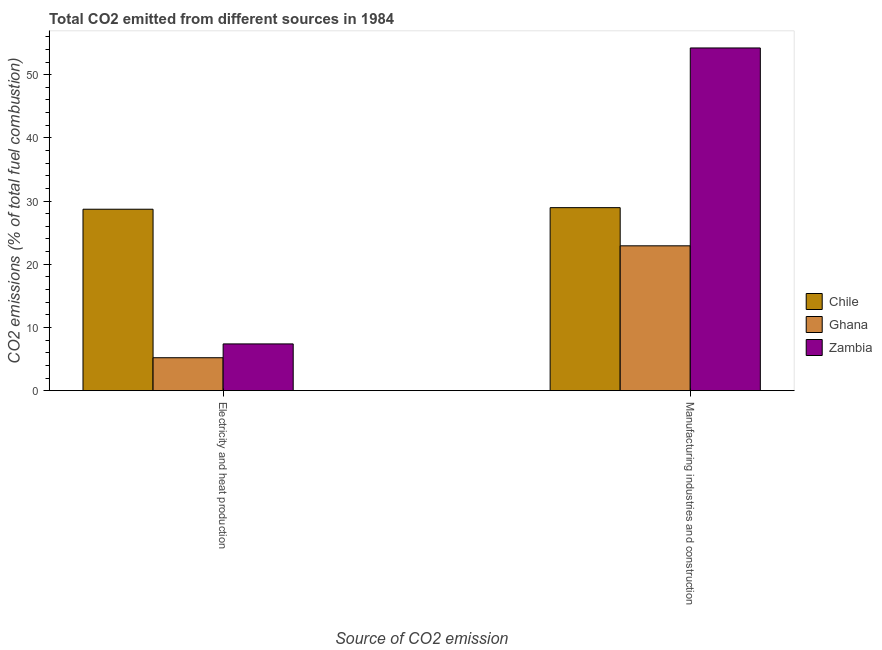How many different coloured bars are there?
Make the answer very short. 3. How many groups of bars are there?
Your response must be concise. 2. Are the number of bars on each tick of the X-axis equal?
Your answer should be compact. Yes. What is the label of the 2nd group of bars from the left?
Your response must be concise. Manufacturing industries and construction. What is the co2 emissions due to electricity and heat production in Zambia?
Offer a very short reply. 7.39. Across all countries, what is the maximum co2 emissions due to manufacturing industries?
Offer a terse response. 54.23. Across all countries, what is the minimum co2 emissions due to electricity and heat production?
Make the answer very short. 5.21. In which country was the co2 emissions due to manufacturing industries minimum?
Keep it short and to the point. Ghana. What is the total co2 emissions due to manufacturing industries in the graph?
Ensure brevity in your answer.  106.1. What is the difference between the co2 emissions due to manufacturing industries in Ghana and that in Chile?
Give a very brief answer. -6.04. What is the difference between the co2 emissions due to manufacturing industries in Chile and the co2 emissions due to electricity and heat production in Zambia?
Your answer should be compact. 21.56. What is the average co2 emissions due to manufacturing industries per country?
Give a very brief answer. 35.37. What is the difference between the co2 emissions due to electricity and heat production and co2 emissions due to manufacturing industries in Zambia?
Your answer should be compact. -46.83. What is the ratio of the co2 emissions due to electricity and heat production in Chile to that in Ghana?
Ensure brevity in your answer.  5.51. Is the co2 emissions due to electricity and heat production in Ghana less than that in Zambia?
Provide a short and direct response. Yes. What does the 2nd bar from the left in Electricity and heat production represents?
Make the answer very short. Ghana. How many bars are there?
Your answer should be very brief. 6. How many legend labels are there?
Ensure brevity in your answer.  3. How are the legend labels stacked?
Your response must be concise. Vertical. What is the title of the graph?
Keep it short and to the point. Total CO2 emitted from different sources in 1984. Does "Isle of Man" appear as one of the legend labels in the graph?
Your response must be concise. No. What is the label or title of the X-axis?
Your answer should be compact. Source of CO2 emission. What is the label or title of the Y-axis?
Make the answer very short. CO2 emissions (% of total fuel combustion). What is the CO2 emissions (% of total fuel combustion) in Chile in Electricity and heat production?
Ensure brevity in your answer.  28.71. What is the CO2 emissions (% of total fuel combustion) in Ghana in Electricity and heat production?
Offer a terse response. 5.21. What is the CO2 emissions (% of total fuel combustion) in Zambia in Electricity and heat production?
Offer a very short reply. 7.39. What is the CO2 emissions (% of total fuel combustion) of Chile in Manufacturing industries and construction?
Keep it short and to the point. 28.96. What is the CO2 emissions (% of total fuel combustion) in Ghana in Manufacturing industries and construction?
Offer a very short reply. 22.92. What is the CO2 emissions (% of total fuel combustion) in Zambia in Manufacturing industries and construction?
Ensure brevity in your answer.  54.23. Across all Source of CO2 emission, what is the maximum CO2 emissions (% of total fuel combustion) in Chile?
Your answer should be very brief. 28.96. Across all Source of CO2 emission, what is the maximum CO2 emissions (% of total fuel combustion) of Ghana?
Give a very brief answer. 22.92. Across all Source of CO2 emission, what is the maximum CO2 emissions (% of total fuel combustion) of Zambia?
Provide a short and direct response. 54.23. Across all Source of CO2 emission, what is the minimum CO2 emissions (% of total fuel combustion) of Chile?
Keep it short and to the point. 28.71. Across all Source of CO2 emission, what is the minimum CO2 emissions (% of total fuel combustion) of Ghana?
Offer a very short reply. 5.21. Across all Source of CO2 emission, what is the minimum CO2 emissions (% of total fuel combustion) of Zambia?
Keep it short and to the point. 7.39. What is the total CO2 emissions (% of total fuel combustion) in Chile in the graph?
Provide a succinct answer. 57.66. What is the total CO2 emissions (% of total fuel combustion) in Ghana in the graph?
Your response must be concise. 28.12. What is the total CO2 emissions (% of total fuel combustion) of Zambia in the graph?
Keep it short and to the point. 61.62. What is the difference between the CO2 emissions (% of total fuel combustion) of Chile in Electricity and heat production and that in Manufacturing industries and construction?
Offer a very short reply. -0.25. What is the difference between the CO2 emissions (% of total fuel combustion) in Ghana in Electricity and heat production and that in Manufacturing industries and construction?
Provide a succinct answer. -17.71. What is the difference between the CO2 emissions (% of total fuel combustion) of Zambia in Electricity and heat production and that in Manufacturing industries and construction?
Your answer should be very brief. -46.83. What is the difference between the CO2 emissions (% of total fuel combustion) of Chile in Electricity and heat production and the CO2 emissions (% of total fuel combustion) of Ghana in Manufacturing industries and construction?
Make the answer very short. 5.79. What is the difference between the CO2 emissions (% of total fuel combustion) in Chile in Electricity and heat production and the CO2 emissions (% of total fuel combustion) in Zambia in Manufacturing industries and construction?
Ensure brevity in your answer.  -25.52. What is the difference between the CO2 emissions (% of total fuel combustion) in Ghana in Electricity and heat production and the CO2 emissions (% of total fuel combustion) in Zambia in Manufacturing industries and construction?
Ensure brevity in your answer.  -49.02. What is the average CO2 emissions (% of total fuel combustion) in Chile per Source of CO2 emission?
Provide a succinct answer. 28.83. What is the average CO2 emissions (% of total fuel combustion) in Ghana per Source of CO2 emission?
Ensure brevity in your answer.  14.06. What is the average CO2 emissions (% of total fuel combustion) in Zambia per Source of CO2 emission?
Offer a terse response. 30.81. What is the difference between the CO2 emissions (% of total fuel combustion) in Chile and CO2 emissions (% of total fuel combustion) in Ghana in Electricity and heat production?
Your answer should be compact. 23.5. What is the difference between the CO2 emissions (% of total fuel combustion) of Chile and CO2 emissions (% of total fuel combustion) of Zambia in Electricity and heat production?
Offer a terse response. 21.31. What is the difference between the CO2 emissions (% of total fuel combustion) in Ghana and CO2 emissions (% of total fuel combustion) in Zambia in Electricity and heat production?
Your response must be concise. -2.19. What is the difference between the CO2 emissions (% of total fuel combustion) in Chile and CO2 emissions (% of total fuel combustion) in Ghana in Manufacturing industries and construction?
Give a very brief answer. 6.04. What is the difference between the CO2 emissions (% of total fuel combustion) of Chile and CO2 emissions (% of total fuel combustion) of Zambia in Manufacturing industries and construction?
Make the answer very short. -25.27. What is the difference between the CO2 emissions (% of total fuel combustion) of Ghana and CO2 emissions (% of total fuel combustion) of Zambia in Manufacturing industries and construction?
Your response must be concise. -31.31. What is the ratio of the CO2 emissions (% of total fuel combustion) of Chile in Electricity and heat production to that in Manufacturing industries and construction?
Provide a short and direct response. 0.99. What is the ratio of the CO2 emissions (% of total fuel combustion) in Ghana in Electricity and heat production to that in Manufacturing industries and construction?
Your answer should be very brief. 0.23. What is the ratio of the CO2 emissions (% of total fuel combustion) in Zambia in Electricity and heat production to that in Manufacturing industries and construction?
Ensure brevity in your answer.  0.14. What is the difference between the highest and the second highest CO2 emissions (% of total fuel combustion) in Chile?
Make the answer very short. 0.25. What is the difference between the highest and the second highest CO2 emissions (% of total fuel combustion) in Ghana?
Your response must be concise. 17.71. What is the difference between the highest and the second highest CO2 emissions (% of total fuel combustion) in Zambia?
Ensure brevity in your answer.  46.83. What is the difference between the highest and the lowest CO2 emissions (% of total fuel combustion) in Chile?
Offer a terse response. 0.25. What is the difference between the highest and the lowest CO2 emissions (% of total fuel combustion) in Ghana?
Keep it short and to the point. 17.71. What is the difference between the highest and the lowest CO2 emissions (% of total fuel combustion) of Zambia?
Offer a terse response. 46.83. 